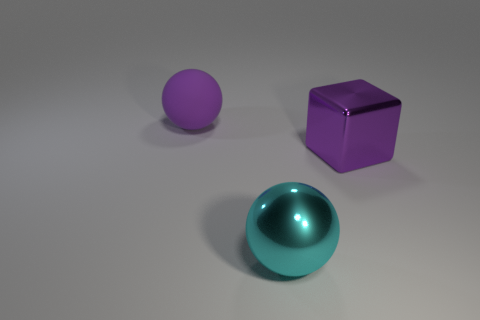Add 2 big cyan shiny balls. How many objects exist? 5 Subtract all blocks. How many objects are left? 2 Subtract all green balls. Subtract all green cylinders. How many balls are left? 2 Subtract all cyan metallic objects. Subtract all big metal balls. How many objects are left? 1 Add 1 big matte objects. How many big matte objects are left? 2 Add 1 purple blocks. How many purple blocks exist? 2 Subtract 0 gray balls. How many objects are left? 3 